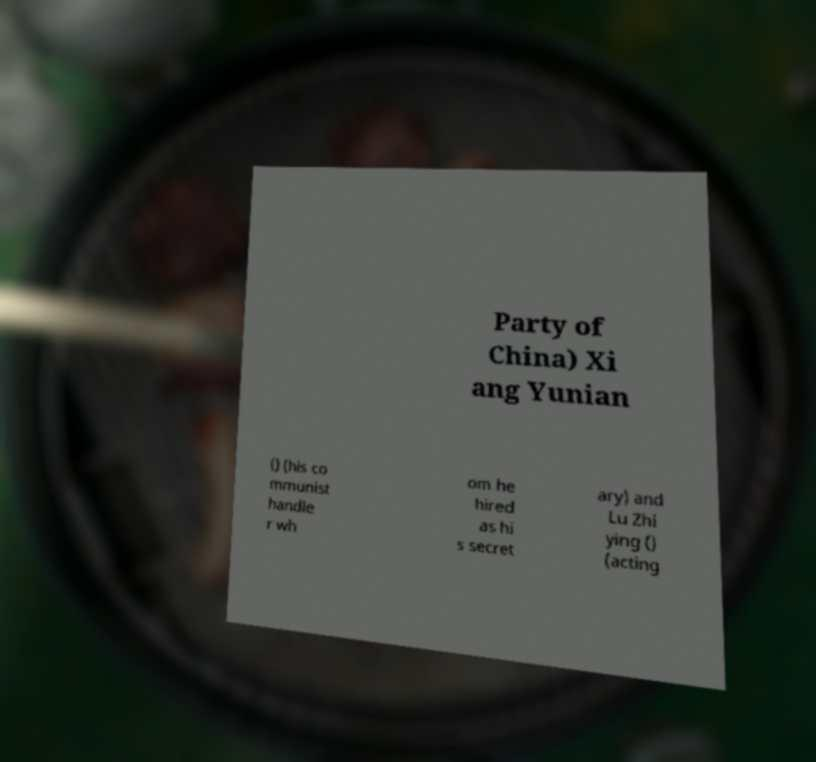Could you extract and type out the text from this image? Party of China) Xi ang Yunian () (his co mmunist handle r wh om he hired as hi s secret ary) and Lu Zhi ying () (acting 